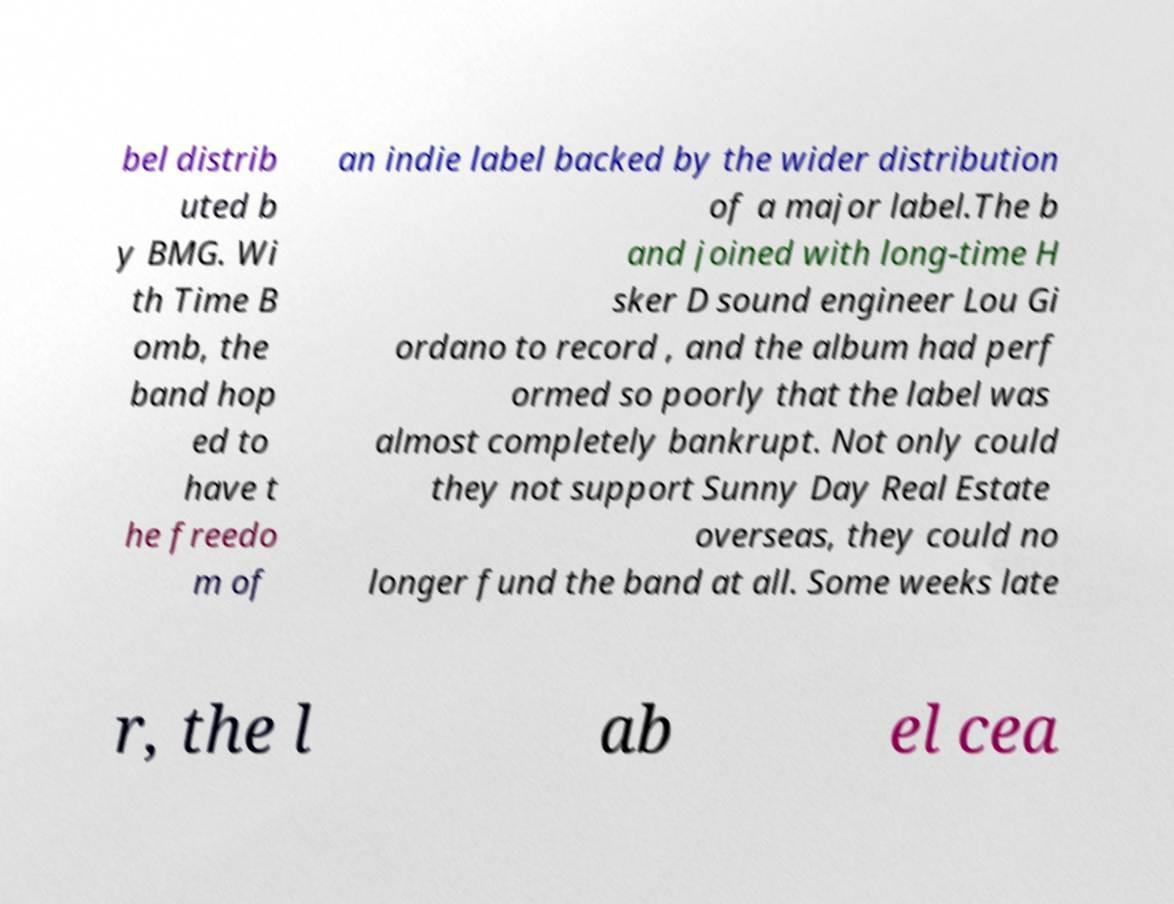I need the written content from this picture converted into text. Can you do that? bel distrib uted b y BMG. Wi th Time B omb, the band hop ed to have t he freedo m of an indie label backed by the wider distribution of a major label.The b and joined with long-time H sker D sound engineer Lou Gi ordano to record , and the album had perf ormed so poorly that the label was almost completely bankrupt. Not only could they not support Sunny Day Real Estate overseas, they could no longer fund the band at all. Some weeks late r, the l ab el cea 